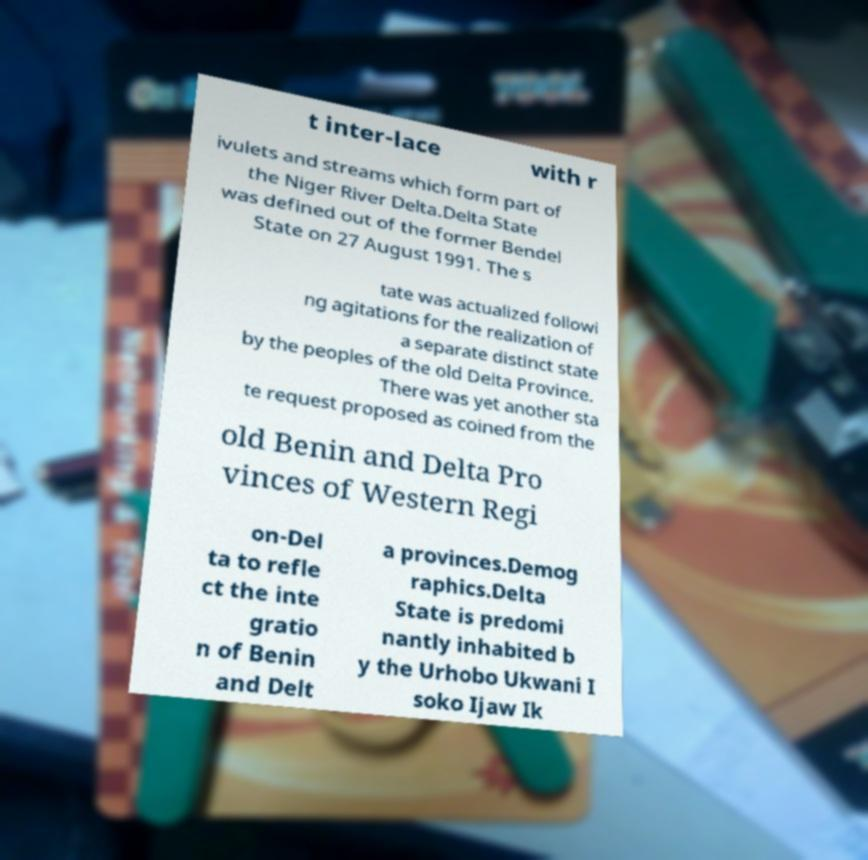Please identify and transcribe the text found in this image. t inter-lace with r ivulets and streams which form part of the Niger River Delta.Delta State was defined out of the former Bendel State on 27 August 1991. The s tate was actualized followi ng agitations for the realization of a separate distinct state by the peoples of the old Delta Province. There was yet another sta te request proposed as coined from the old Benin and Delta Pro vinces of Western Regi on-Del ta to refle ct the inte gratio n of Benin and Delt a provinces.Demog raphics.Delta State is predomi nantly inhabited b y the Urhobo Ukwani I soko Ijaw Ik 